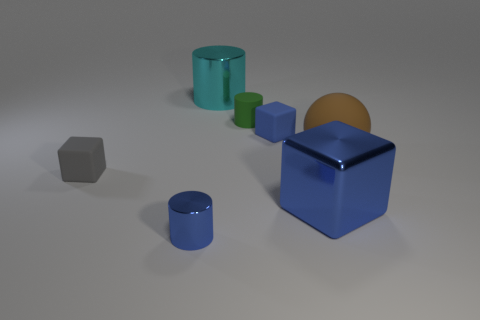Subtract 1 cylinders. How many cylinders are left? 2 Add 3 metal cubes. How many objects exist? 10 Subtract all cylinders. How many objects are left? 4 Subtract all cyan cylinders. Subtract all metal cylinders. How many objects are left? 4 Add 6 blue cylinders. How many blue cylinders are left? 7 Add 5 large green shiny blocks. How many large green shiny blocks exist? 5 Subtract 0 yellow balls. How many objects are left? 7 